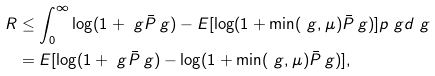Convert formula to latex. <formula><loc_0><loc_0><loc_500><loc_500>R & \leq \int _ { 0 } ^ { \infty } \log ( 1 + \ g \bar { P } _ { \ } g ) - E [ \log ( 1 + \min ( \ g , \mu ) \bar { P } _ { \ } g ) ] p _ { \ } g d \ g \\ & = E [ \log ( 1 + \ g \bar { P } _ { \ } g ) - \log ( 1 + \min ( \ g , \mu ) \bar { P } _ { \ } g ) ] ,</formula> 